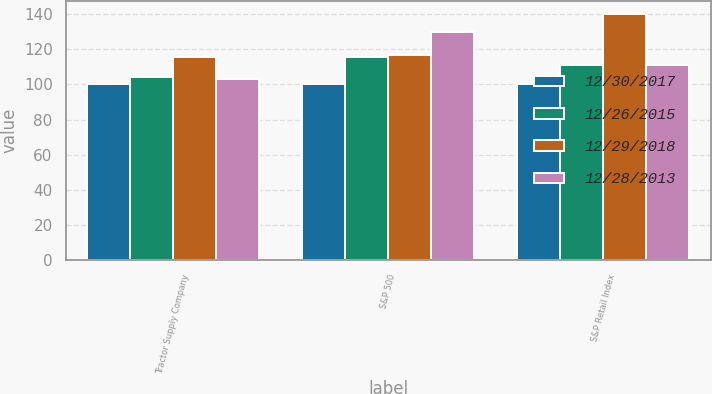Convert chart. <chart><loc_0><loc_0><loc_500><loc_500><stacked_bar_chart><ecel><fcel>Tractor Supply Company<fcel>S&P 500<fcel>S&P Retail Index<nl><fcel>12/30/2017<fcel>100<fcel>100<fcel>100<nl><fcel>12/26/2015<fcel>104.11<fcel>115.76<fcel>111.18<nl><fcel>12/29/2018<fcel>115.45<fcel>116.64<fcel>140.22<nl><fcel>12/28/2013<fcel>103.33<fcel>129.55<fcel>111.18<nl></chart> 